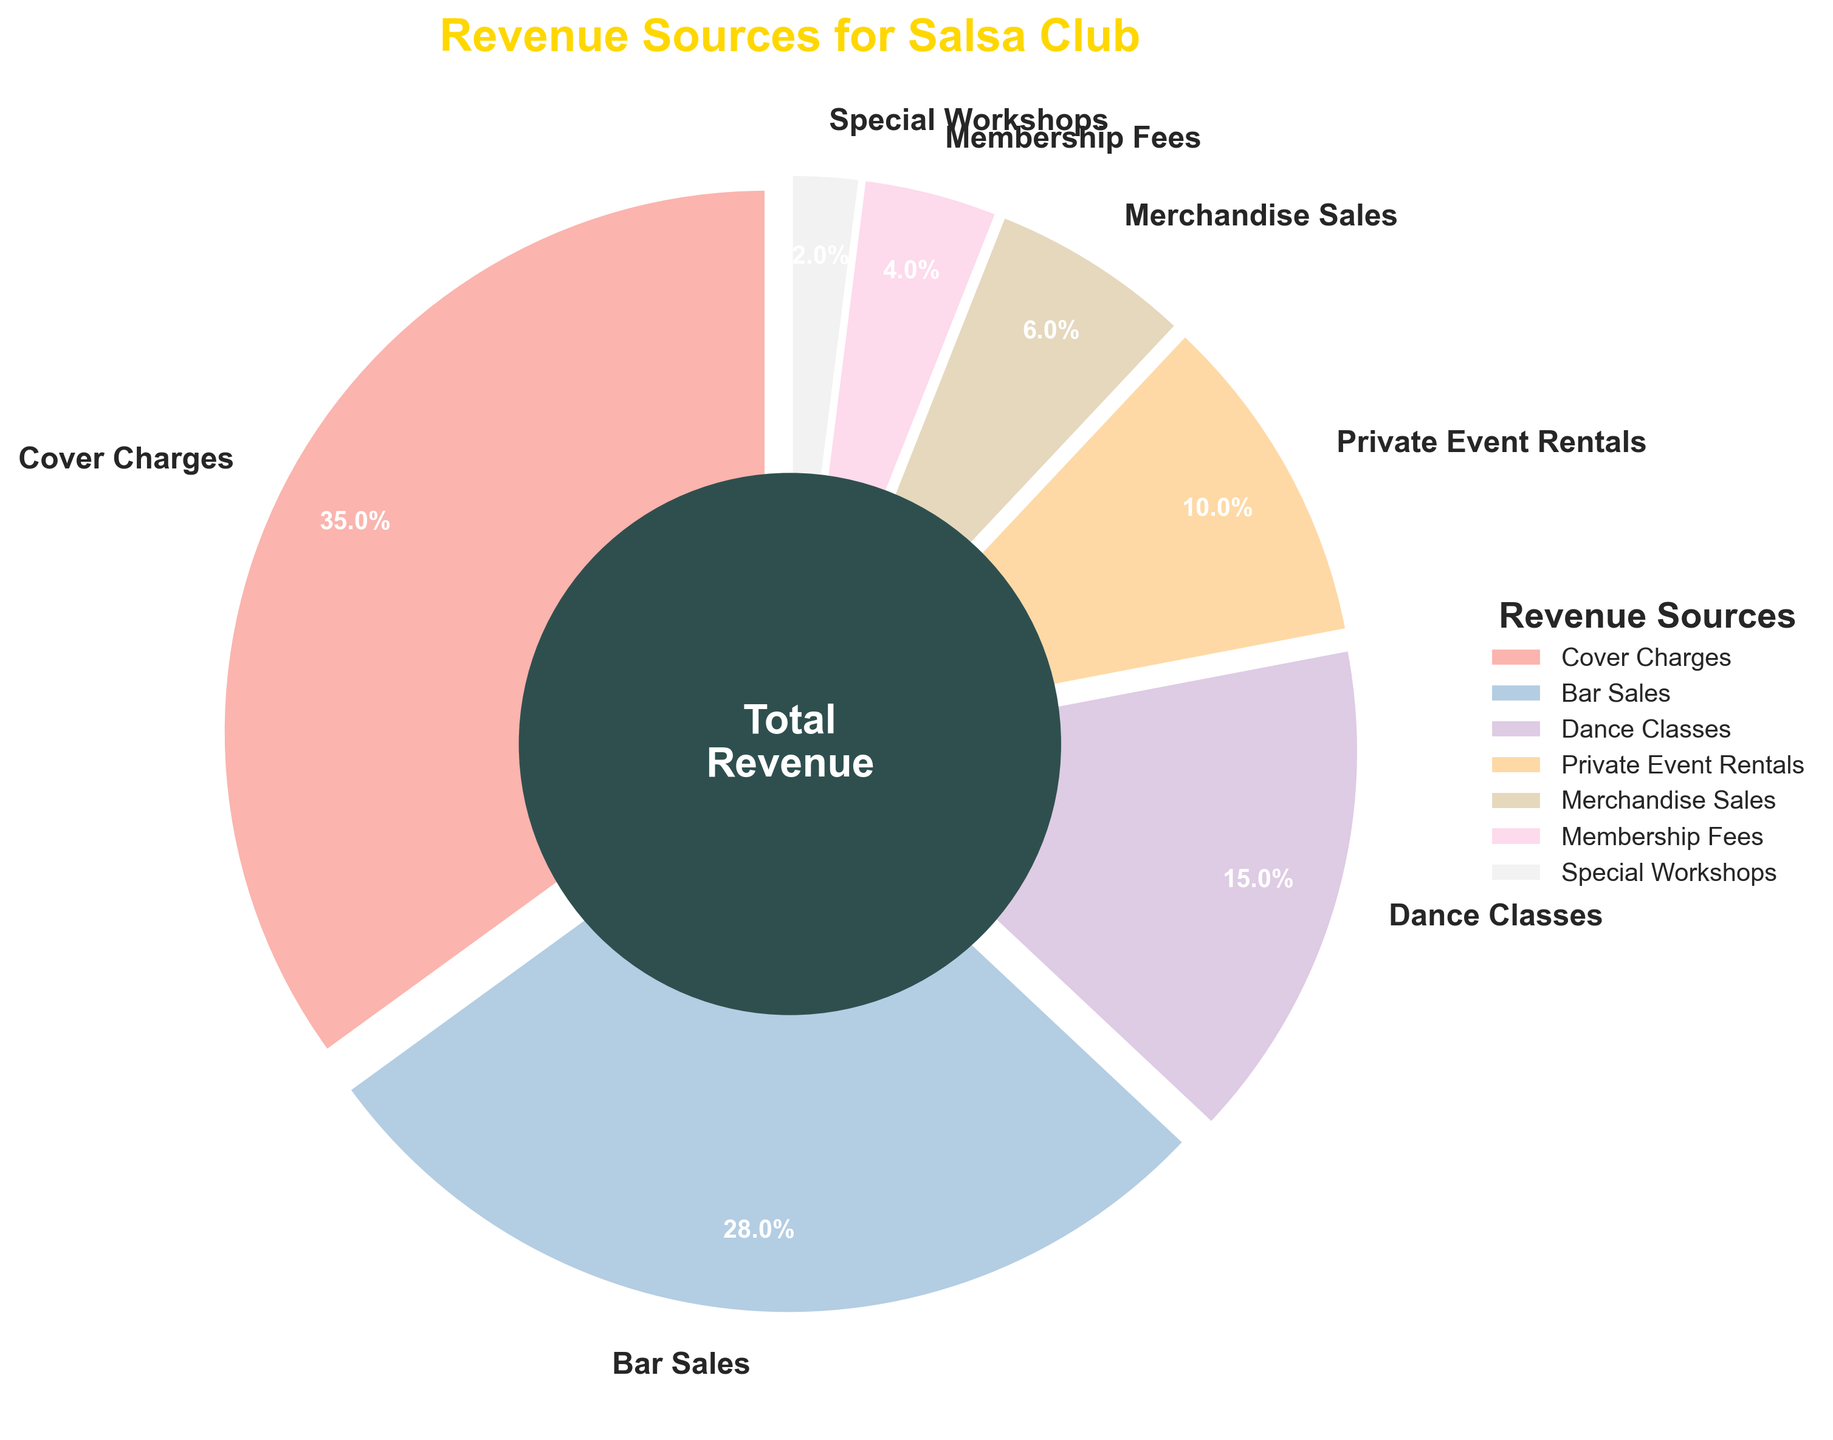What is the revenue percentage from Cover Charges? The pie chart shows that Cover Charges contribute 35% to the total revenue. This can be directly seen as it is marked on the chart.
Answer: 35% Which revenue source contributes the least to the salsa club's revenue? The pie chart indicates different segments with their percentages. The smallest segment, labeled with 2%, represents Special Workshops, which is the least contributing revenue source.
Answer: Special Workshops How much higher is the revenue from Bar Sales compared to Membership Fees? From the pie chart, Bar Sales contribute 28% and Membership Fees contribute 4%. The difference is calculated as 28% - 4% = 24%.
Answer: 24% What are the combined revenue percentages from Dance Classes and Private Event Rentals? According to the pie chart, Dance Classes contribute 15%, and Private Event Rentals contribute 10%. Adding these together results in 15% + 10% = 25%.
Answer: 25% Between Cover Charges and Merchandise Sales, which generates more revenue and by how much? Cover Charges generate 35% and Merchandise Sales generate 6%. The difference between them is 35% - 6% = 29%.
Answer: Cover Charges by 29% Which two revenue sources combined contribute the same percentage as the Bar Sales alone? Bar Sales contribute 28%. Checking the chart, Dance Classes (15%) and Private Event Rentals (10%) together total 25%, which is not equal. However, Merchandise Sales (6%) and Dance Classes (15%) together total 21%. The correct pair is Dance Classes (15%) and Private Event Rentals (10%), combined 25%, which is closest to Bar Sales alone.
Answer: None exactly match; closest is Dance Classes and Merchandise Sales, total 21% What percentage of the salsa club's revenue is not generated from Cover Charges and Bar Sales? The total revenue excluding Cover Charges (35%) and Bar Sales (28%) is 100% - 35% - 28% = 37%.
Answer: 37% How many revenue sources contribute less than 10% to the salsa club's revenue? The pie chart shows sources with less than 10% are Private Event Rentals (10%), Merchandise Sales (6%), Membership Fees (4%), and Special Workshops (2%). There are four sources.
Answer: 4 What visual attribute describes the slice representing Merchandise Sales? In the pie chart, the slice representing Merchandise Sales is exploded slightly from the center like all other slices, has its label, and is a specific color as part of the color palette used. The percentage is 6%.
Answer: Exploded slice, 6% Does Dance Classes contribute more to the revenue than Private Event Rentals and Membership Fees combined? Dance Classes contribute 15%. Private Event Rentals contribute 10% and Membership Fees contribute 4%. Combined, these are 10% + 4% = 14%, which is less than 15%.
Answer: Yes 